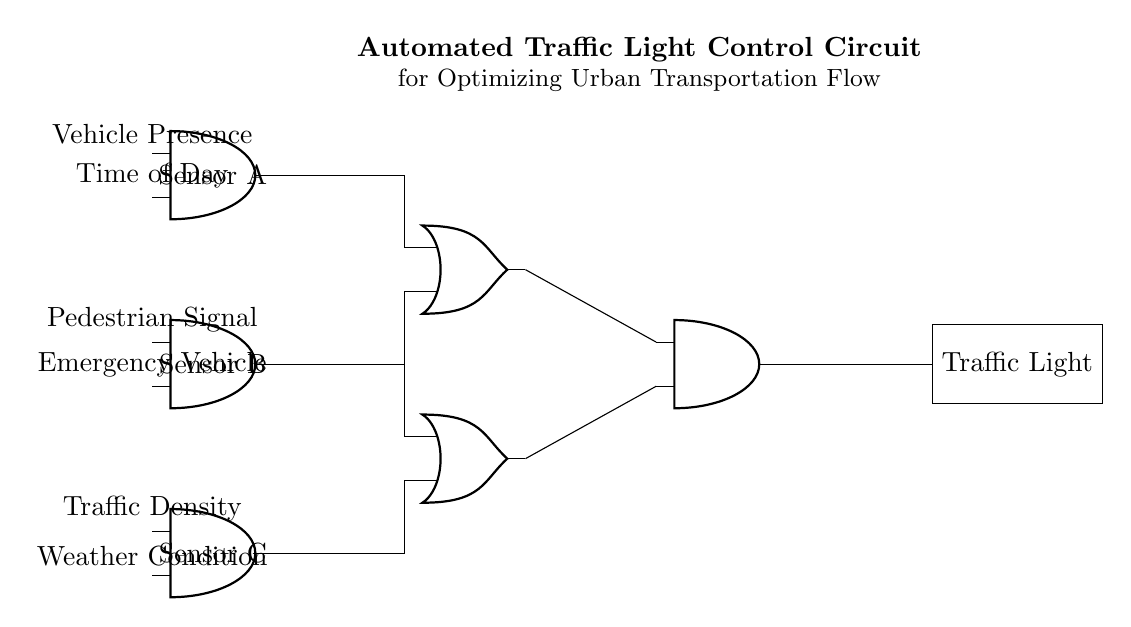What is the output component of this circuit? The output component is the Traffic Light, which is indicated by the rectangle labeled 'Traffic Light.' It's the final result of the logic operations applied in the circuit.
Answer: Traffic Light How many AND gates are present in the circuit? The circuit contains three AND gates, as seen from the three nodes labeled A1, A2, and A3, which are all AND ports.
Answer: Three What conditions does Sensor A measure? Sensor A measures Vehicle Presence and Time of Day, as indicated by the labels directly above its input connections.
Answer: Vehicle Presence and Time of Day What is the purpose of the OR gates in this circuit? The OR gates (O1 and O2) combine the outputs from the different sensors, determining whether any of the conditions from the AND gates are met for further processing in the final AND gate.
Answer: To combine sensor outputs Which sensor is connected to the emergency vehicle input? Sensor B is connected to the Emergency Vehicle input, as labeled above its input connection.
Answer: Sensor B What is the final decision point in the circuit? The final decision point in the circuit is the last AND gate (A4), which takes the outputs from both OR gates to determine the state of the Traffic Light.
Answer: Last AND gate Which sensor assesses environmental impact on traffic? Sensor C assesses the Weather Condition, as indicated on its input connection. It's crucial for adapting traffic light responses based on environmental factors.
Answer: Sensor C 